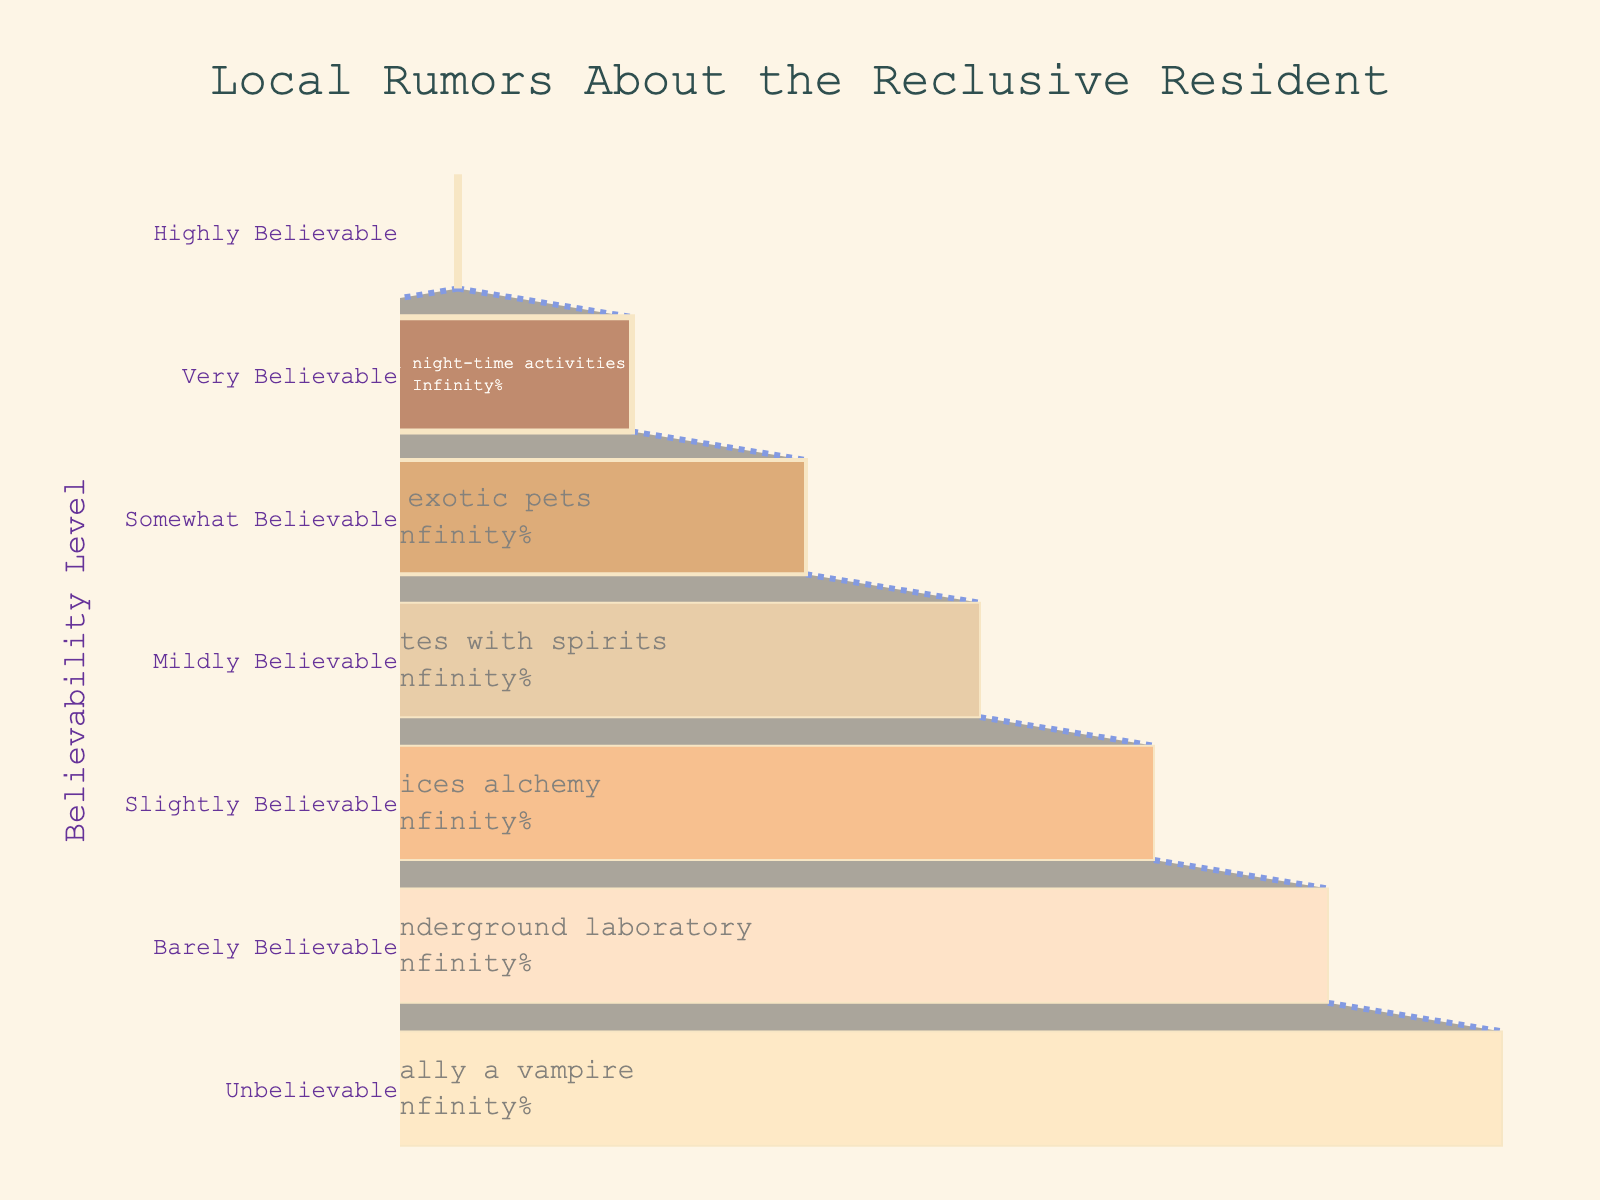What is the title of the funnel chart? The title is located at the top of the figure, written in a larger font size and easily noticeable.
Answer: Local Rumors About the Reclusive Resident How many levels of believability are present in the chart? Count the distinct sections in the funnel, each representing a different believability category.
Answer: Seven Which rumor is considered the least believable? Identify the category with the lowest believability level, which is typically at the narrower end of the funnel chart.
Answer: Is actually a vampire What is the difference in believability between the top two categories? Subtract the believability of the second category from the believability of the first category. The top two categories are 'Highly Believable' and 'Very Believable'.
Answer: 15 Which misconceived belief is in the middle of the believability spectrum? Locate the central category in the funnel chart, which is typically halfway down the chart.
Answer: Communicates with spirits How does the believability of owning exotic pets compare to practicing alchemy? Compare the numerical values of believability for these two rumors.
Answer: Higher What percentage of the total initial value does the 'Very Believable' category represent? Find the percentage label inside the 'Very Believable' funnel section.
Answer: 85% Which two categories have a believability difference of 30? Look for pairs of categories where the difference in their believability values equals 30; this requires basic subtraction.
Answer: Practices alchemy and Rarely leaves house What color represents the 'Barely Believable' rumor? Observe the funnel section labeled 'Barely Believable' and note its color.
Answer: Light apricot (or similar light shade) If you sum up the believability of 'Has unusual night-time activities' and 'Practices alchemy', what is the result? Add the believability values for these two categories: 85 (Very Believable) and 40 (Slightly Believable).
Answer: 125 